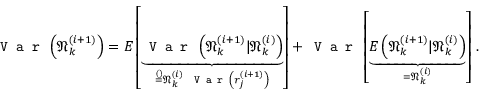<formula> <loc_0><loc_0><loc_500><loc_500>V a r \left ( \mathfrak { N } _ { k } ^ { ( i + 1 ) } \right ) = E \left [ \underbrace { V a r \left ( \mathfrak { N } _ { k } ^ { ( i + 1 ) } | \mathfrak { N } _ { k } ^ { ( i ) } \right ) } _ { \stackrel { ( ) } { = } \mathfrak { N } _ { k } ^ { ( i ) } V a r \left ( r _ { j } ^ { ( i + 1 ) } \right ) } \right ] + V a r \left [ \underbrace { E \left ( \mathfrak { N } _ { k } ^ { ( i + 1 ) } | \mathfrak { N } _ { k } ^ { ( i ) } \right ) } _ { = \mathfrak { N } _ { k } ^ { ( i ) } } \right ] \, .</formula> 